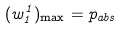Convert formula to latex. <formula><loc_0><loc_0><loc_500><loc_500>( w _ { 1 } ^ { 1 } ) _ { \max } = p _ { a b s }</formula> 